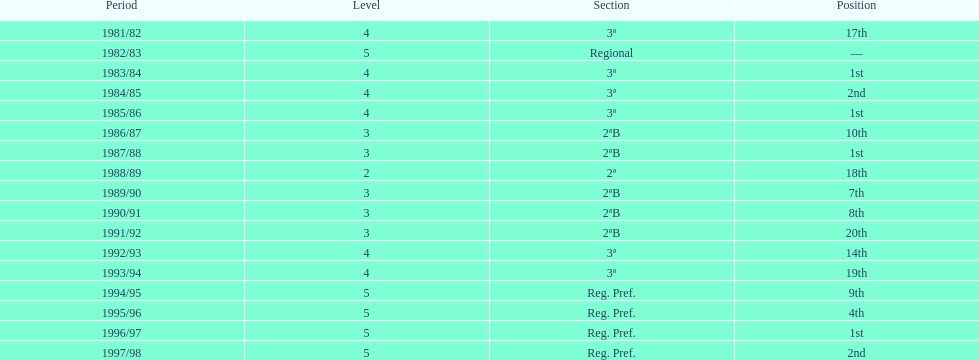Could you parse the entire table? {'header': ['Period', 'Level', 'Section', 'Position'], 'rows': [['1981/82', '4', '3ª', '17th'], ['1982/83', '5', 'Regional', '—'], ['1983/84', '4', '3ª', '1st'], ['1984/85', '4', '3ª', '2nd'], ['1985/86', '4', '3ª', '1st'], ['1986/87', '3', '2ªB', '10th'], ['1987/88', '3', '2ªB', '1st'], ['1988/89', '2', '2ª', '18th'], ['1989/90', '3', '2ªB', '7th'], ['1990/91', '3', '2ªB', '8th'], ['1991/92', '3', '2ªB', '20th'], ['1992/93', '4', '3ª', '14th'], ['1993/94', '4', '3ª', '19th'], ['1994/95', '5', 'Reg. Pref.', '9th'], ['1995/96', '5', 'Reg. Pref.', '4th'], ['1996/97', '5', 'Reg. Pref.', '1st'], ['1997/98', '5', 'Reg. Pref.', '2nd']]} How many years were they in tier 3 5. 